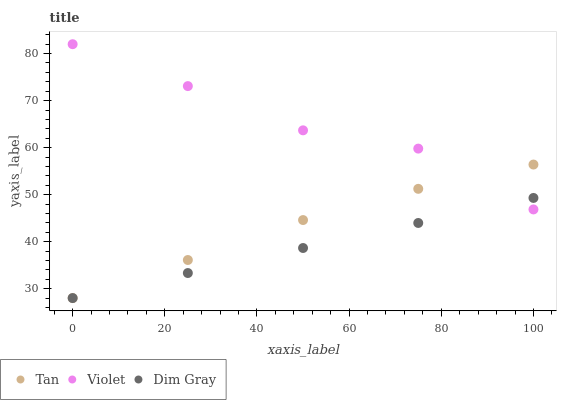Does Dim Gray have the minimum area under the curve?
Answer yes or no. Yes. Does Violet have the maximum area under the curve?
Answer yes or no. Yes. Does Violet have the minimum area under the curve?
Answer yes or no. No. Does Dim Gray have the maximum area under the curve?
Answer yes or no. No. Is Dim Gray the smoothest?
Answer yes or no. Yes. Is Violet the roughest?
Answer yes or no. Yes. Is Violet the smoothest?
Answer yes or no. No. Is Dim Gray the roughest?
Answer yes or no. No. Does Tan have the lowest value?
Answer yes or no. Yes. Does Violet have the lowest value?
Answer yes or no. No. Does Violet have the highest value?
Answer yes or no. Yes. Does Dim Gray have the highest value?
Answer yes or no. No. Does Violet intersect Tan?
Answer yes or no. Yes. Is Violet less than Tan?
Answer yes or no. No. Is Violet greater than Tan?
Answer yes or no. No. 